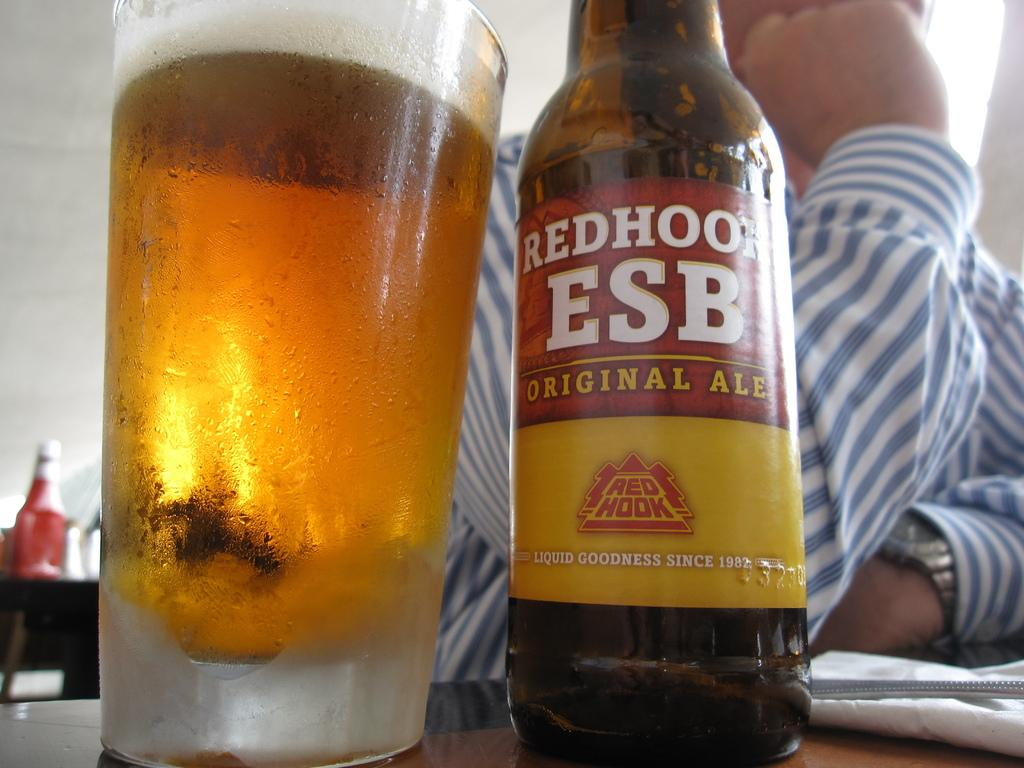<image>
Render a clear and concise summary of the photo. A bottle advertises being an original ale on the label. 